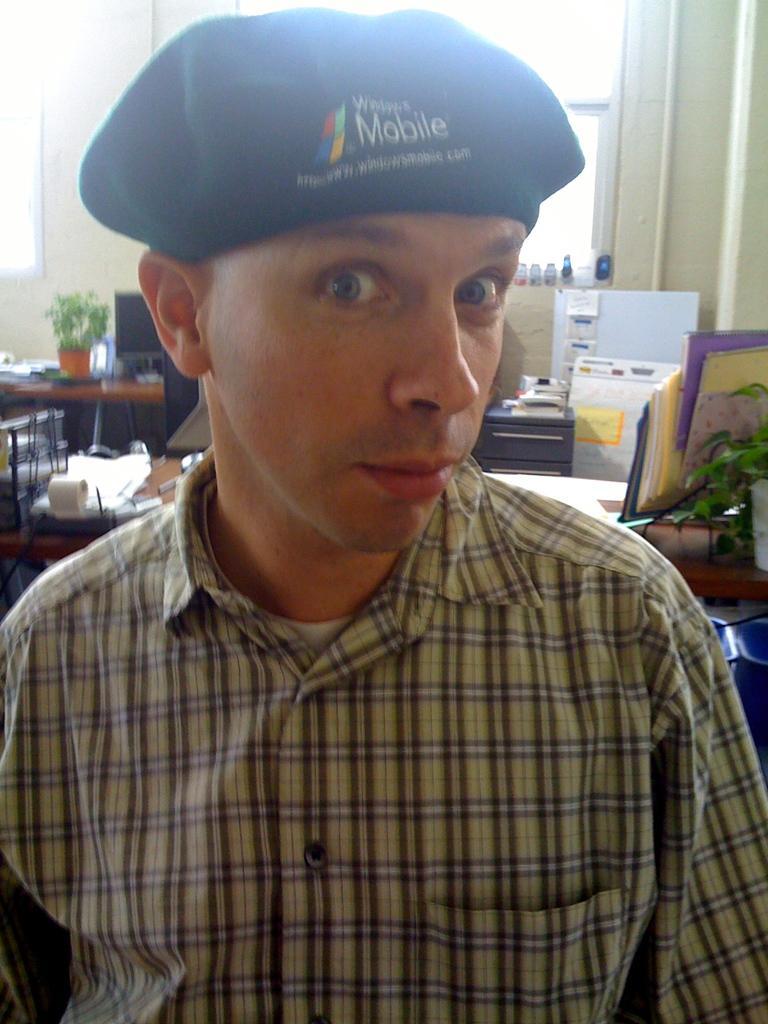Please provide a concise description of this image. In the image there is a man with a cap on the head. On the cap there is something written on it. Behind the man there is a table with papers, plant with leaves, pot, monitor and some other items on it. In the background there is a wall with windows. 